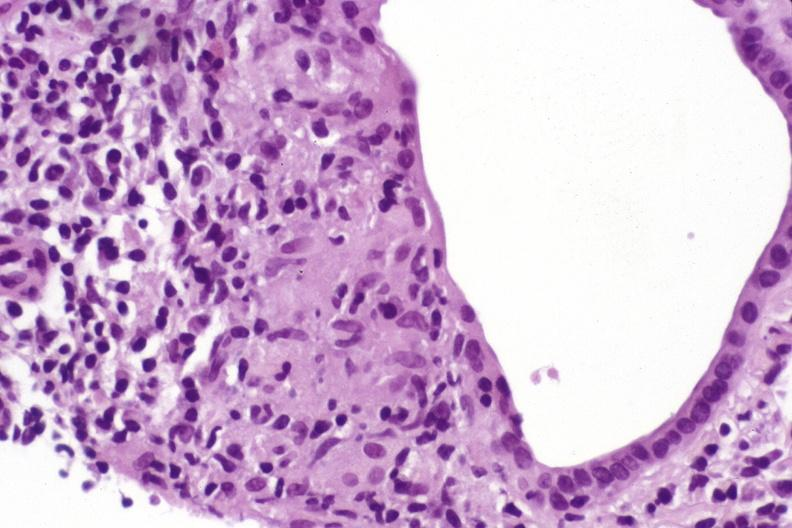what is present?
Answer the question using a single word or phrase. Hepatobiliary 